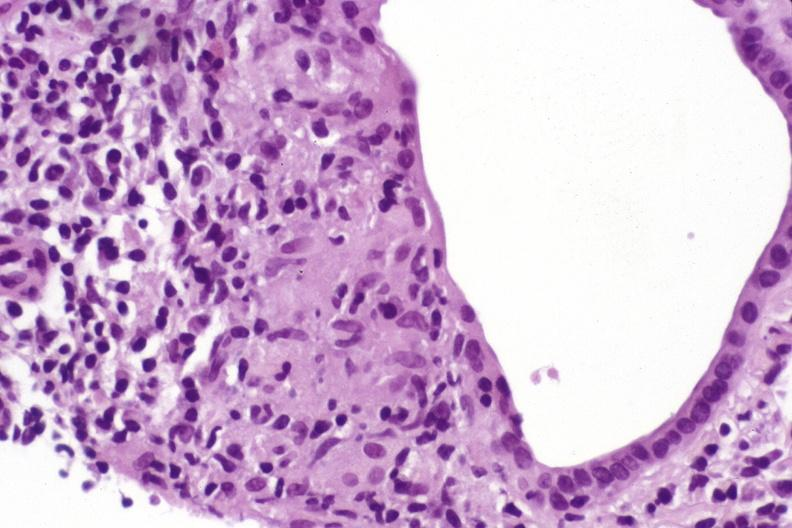what is present?
Answer the question using a single word or phrase. Hepatobiliary 